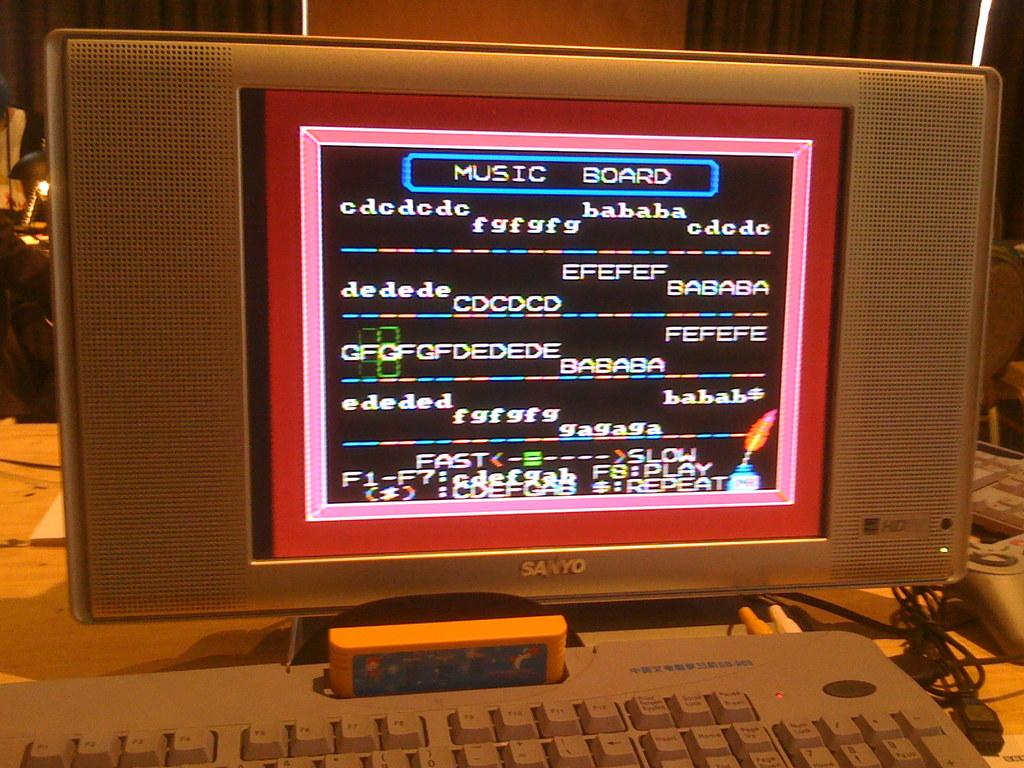<image>
Give a short and clear explanation of the subsequent image. A music board in which music producers make music. 